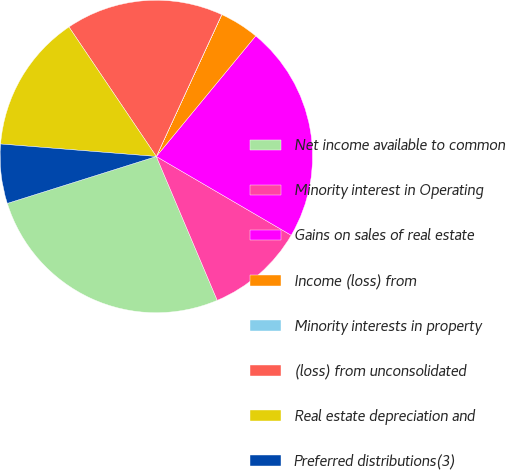Convert chart. <chart><loc_0><loc_0><loc_500><loc_500><pie_chart><fcel>Net income available to common<fcel>Minority interest in Operating<fcel>Gains on sales of real estate<fcel>Income (loss) from<fcel>Minority interests in property<fcel>(loss) from unconsolidated<fcel>Real estate depreciation and<fcel>Preferred distributions(3)<nl><fcel>26.52%<fcel>10.21%<fcel>22.44%<fcel>4.09%<fcel>0.01%<fcel>16.32%<fcel>14.28%<fcel>6.13%<nl></chart> 